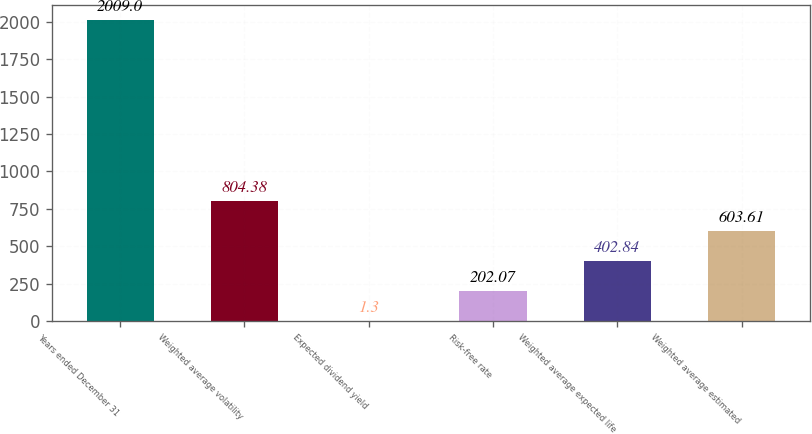Convert chart to OTSL. <chart><loc_0><loc_0><loc_500><loc_500><bar_chart><fcel>Years ended December 31<fcel>Weighted average volatility<fcel>Expected dividend yield<fcel>Risk-free rate<fcel>Weighted average expected life<fcel>Weighted average estimated<nl><fcel>2009<fcel>804.38<fcel>1.3<fcel>202.07<fcel>402.84<fcel>603.61<nl></chart> 